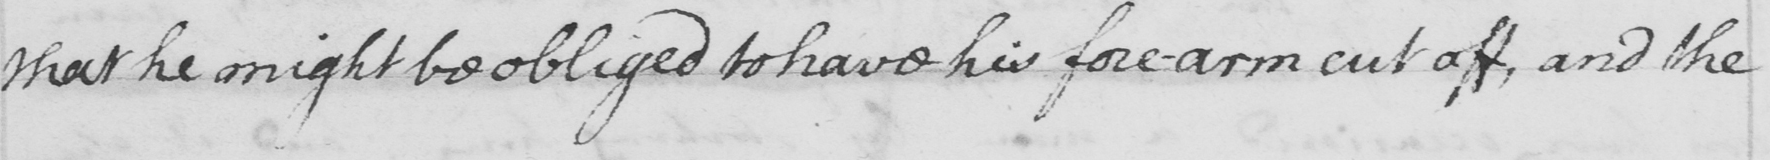Please transcribe the handwritten text in this image. that he might be obliged to have his fore-arm cut off, and the 